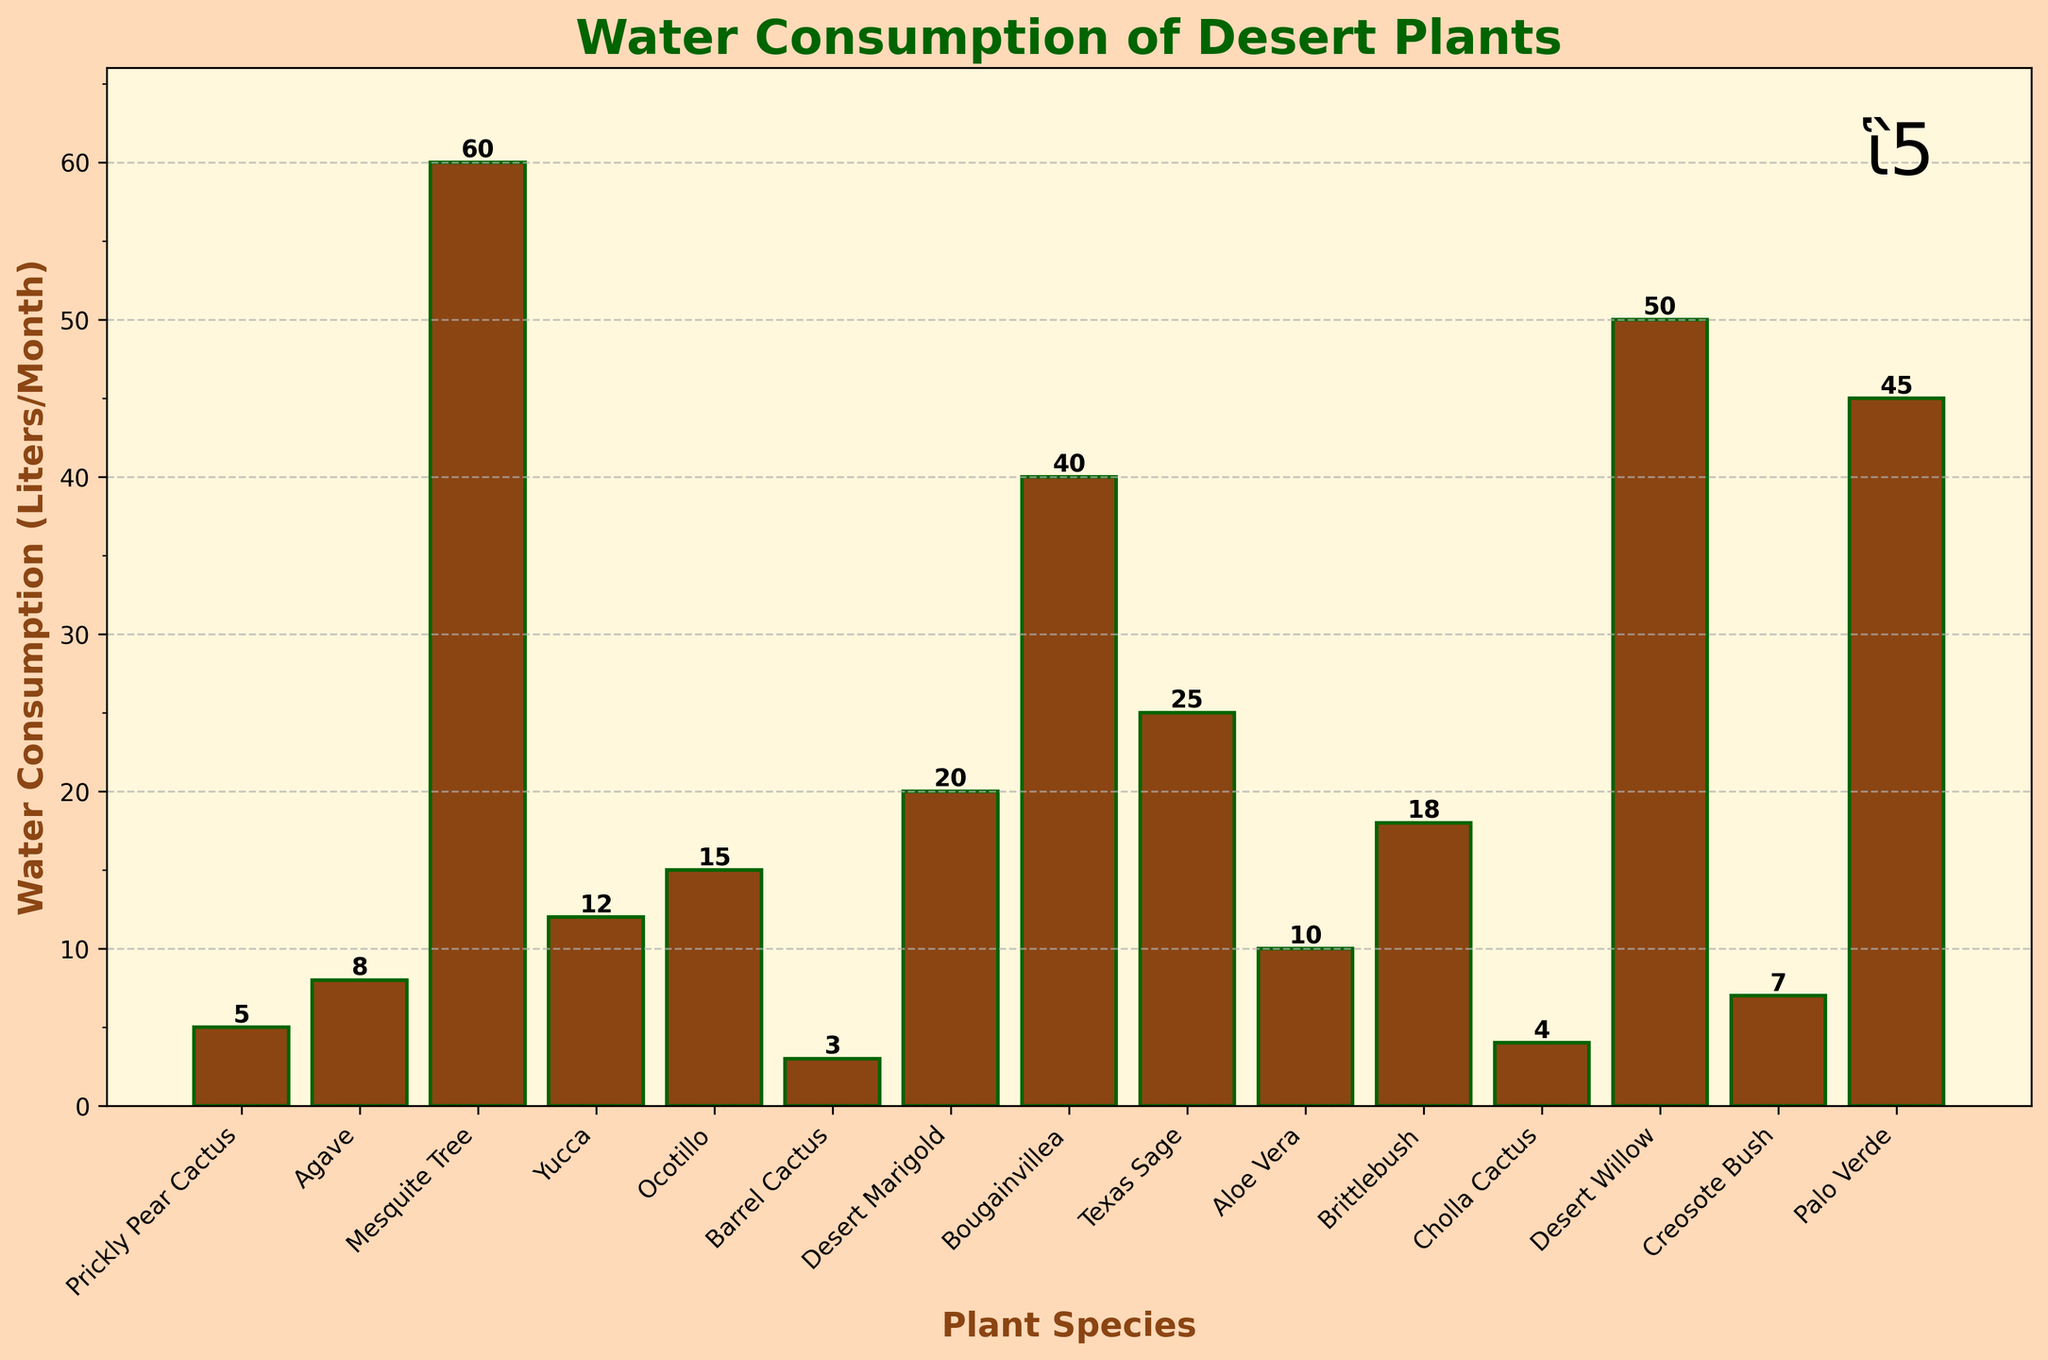what is the plant with the highest water consumption? Look at the heights of all the bars to find the highest one, which corresponds to the Mesquite Tree.
Answer: Mesquite Tree which plant consumes less water, agave or ocotillo? Compare the heights of the bars for Agave and Ocotillo; Agave is 8 Liters/Month and Ocotillo is 15 Liters/Month.
Answer: Agave what's the total water consumption of yucca, aloe vera, and brittlebush combined? Add the water consumption values for Yucca (12), Aloe Vera (10), and Brittlebush (18). 12 + 10 + 18 = 40
Answer: 40 which plant has a lower water consumption: creosote bush or bougainvillea? Compare the heights of the bars for Creosote Bush and Bougainvillea; Creosote Bush is 7 Liters/Month and Bougainvillea is 40 Liters/Month.
Answer: Creosote Bush what is the average water consumption of all the plants? Sum up the water consumptions and divide by the number of plants. The sum is 330, and there are 15 plants, so 330 / 15 = 22.
Answer: 22 is the water consumption of the desert willow greater than or less than the palo verde? Compare the heights of the bars for Desert Willow and Palo Verde; Desert Willow is 50 Liters/Month and Palo Verde is 45 Liters/Month.
Answer: Greater than Which plants consume exactly 25 liters of water per month? Look at the heights of all the bars to find any that are exactly at 25 Liters/Month, which corresponds to Texas Sage.
Answer: Texas Sage Rank the top three plants with the highest water consumption. Identify and list the three tallest bars, which are Mesquite Tree (60), Desert Willow (50), and Palo Verde (45).
Answer: Mesquite Tree, Desert Willow, Palo Verde What's the difference in water consumption between barrel cactus and cholla cactus? Subtract the water consumption of Cholla Cactus (4) from Barrel Cactus (3). 4 - 3 = 1
Answer: 1 Which plant's bar is the least visually prominent, indicating the lowest water consumption? Identify the shortest bar in the chart, which corresponds to Barrel Cactus.
Answer: Barrel Cactus 